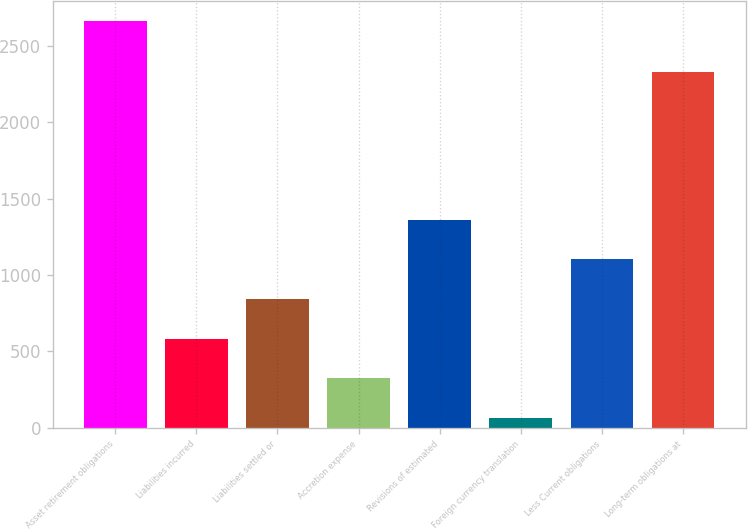Convert chart. <chart><loc_0><loc_0><loc_500><loc_500><bar_chart><fcel>Asset retirement obligations<fcel>Liabilities incurred<fcel>Liabilities settled or<fcel>Accretion expense<fcel>Revisions of estimated<fcel>Foreign currency translation<fcel>Less Current obligations<fcel>Long-term obligations at<nl><fcel>2661<fcel>583.4<fcel>843.1<fcel>323.7<fcel>1362.5<fcel>64<fcel>1102.8<fcel>2330.7<nl></chart> 